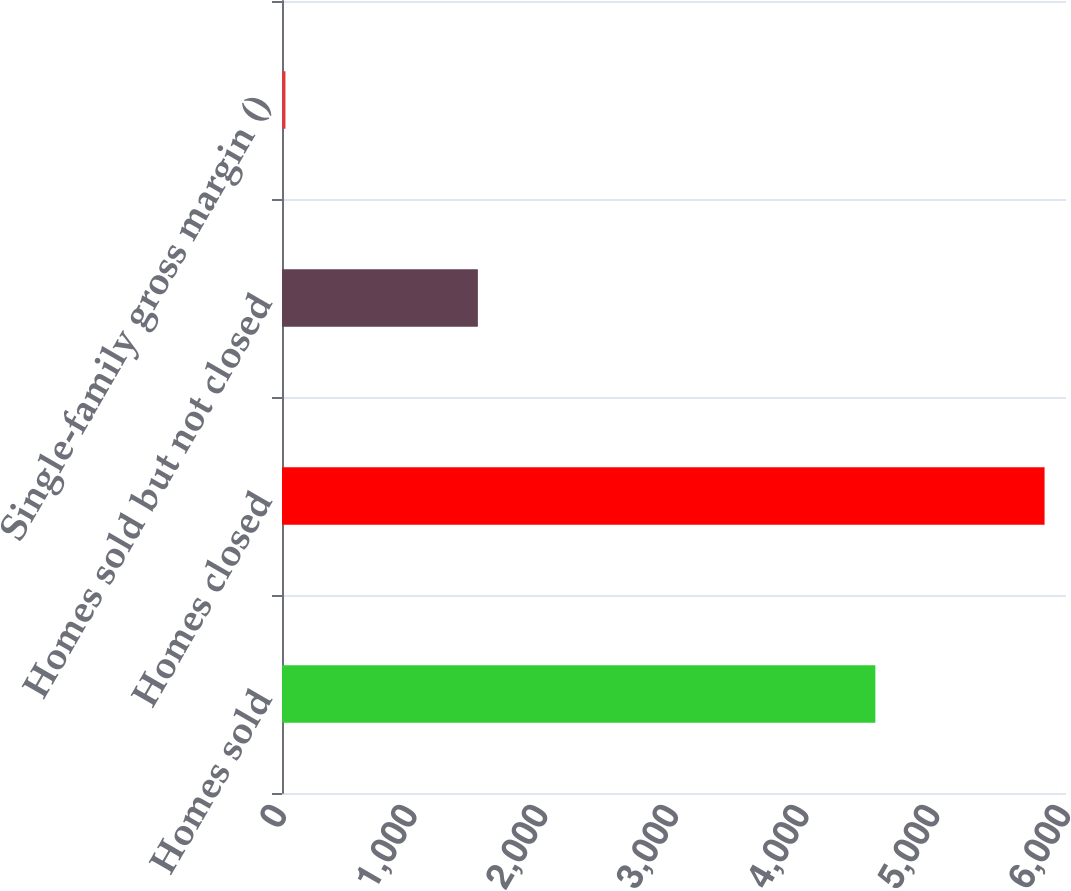<chart> <loc_0><loc_0><loc_500><loc_500><bar_chart><fcel>Homes sold<fcel>Homes closed<fcel>Homes sold but not closed<fcel>Single-family gross margin ()<nl><fcel>4541<fcel>5836<fcel>1499<fcel>26.5<nl></chart> 